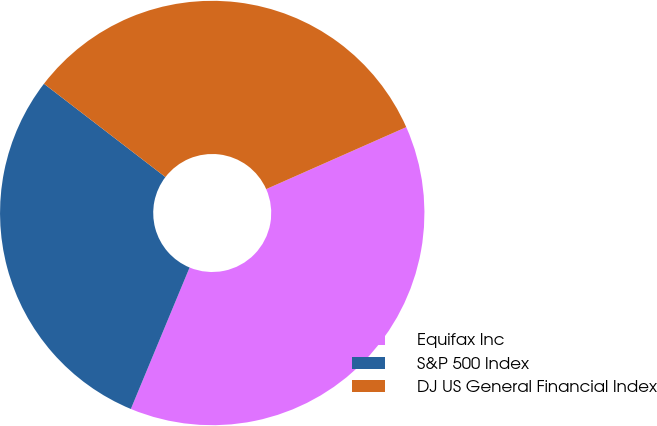Convert chart. <chart><loc_0><loc_0><loc_500><loc_500><pie_chart><fcel>Equifax Inc<fcel>S&P 500 Index<fcel>DJ US General Financial Index<nl><fcel>37.89%<fcel>29.16%<fcel>32.94%<nl></chart> 